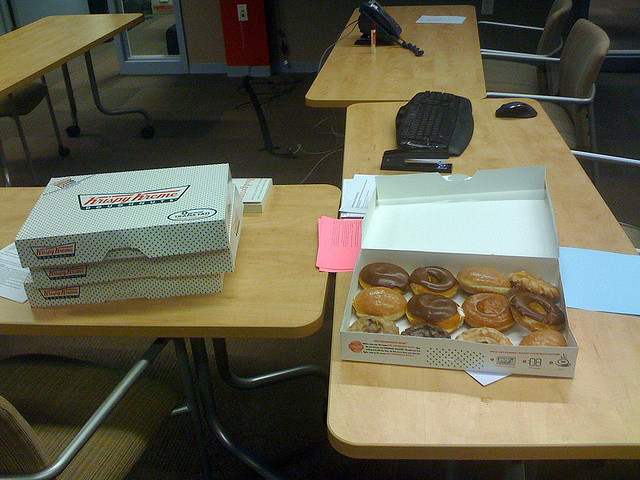<image>Are those donuts for ME??? I don't know if those donuts are for you. Are those donuts for ME??? I don't know if those donuts are for you. It is unclear whether they are for you or not. 